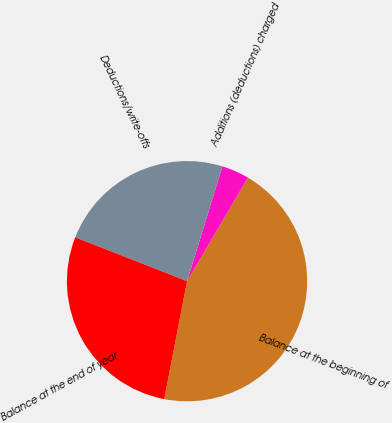Convert chart to OTSL. <chart><loc_0><loc_0><loc_500><loc_500><pie_chart><fcel>Balance at the beginning of<fcel>Additions (deductions) charged<fcel>Deductions/write-offs<fcel>Balance at the end of year<nl><fcel>44.57%<fcel>3.71%<fcel>23.81%<fcel>27.9%<nl></chart> 